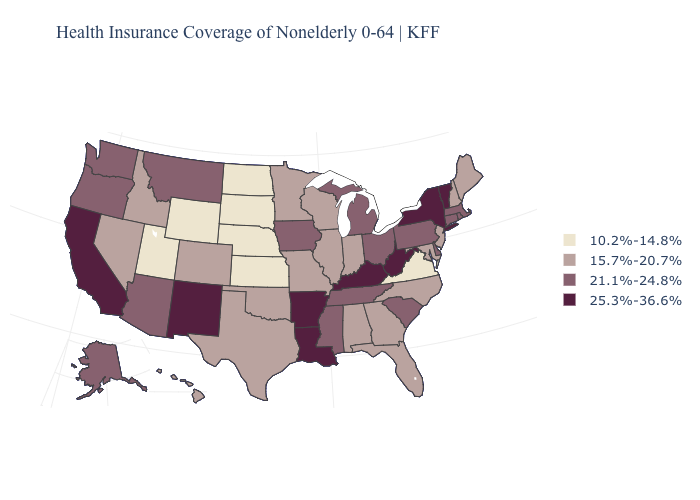Does Minnesota have a higher value than Texas?
Answer briefly. No. How many symbols are there in the legend?
Give a very brief answer. 4. Among the states that border Washington , which have the highest value?
Give a very brief answer. Oregon. Does Iowa have a higher value than Oregon?
Answer briefly. No. What is the value of Alaska?
Keep it brief. 21.1%-24.8%. Which states have the lowest value in the Northeast?
Short answer required. Maine, New Hampshire, New Jersey. Among the states that border Texas , which have the lowest value?
Keep it brief. Oklahoma. Name the states that have a value in the range 15.7%-20.7%?
Quick response, please. Alabama, Colorado, Florida, Georgia, Hawaii, Idaho, Illinois, Indiana, Maine, Maryland, Minnesota, Missouri, Nevada, New Hampshire, New Jersey, North Carolina, Oklahoma, Texas, Wisconsin. Does the map have missing data?
Quick response, please. No. Name the states that have a value in the range 10.2%-14.8%?
Write a very short answer. Kansas, Nebraska, North Dakota, South Dakota, Utah, Virginia, Wyoming. Does West Virginia have the highest value in the USA?
Answer briefly. Yes. Does Iowa have the highest value in the MidWest?
Short answer required. Yes. Which states have the lowest value in the USA?
Give a very brief answer. Kansas, Nebraska, North Dakota, South Dakota, Utah, Virginia, Wyoming. Name the states that have a value in the range 21.1%-24.8%?
Write a very short answer. Alaska, Arizona, Connecticut, Delaware, Iowa, Massachusetts, Michigan, Mississippi, Montana, Ohio, Oregon, Pennsylvania, Rhode Island, South Carolina, Tennessee, Washington. Name the states that have a value in the range 15.7%-20.7%?
Write a very short answer. Alabama, Colorado, Florida, Georgia, Hawaii, Idaho, Illinois, Indiana, Maine, Maryland, Minnesota, Missouri, Nevada, New Hampshire, New Jersey, North Carolina, Oklahoma, Texas, Wisconsin. 